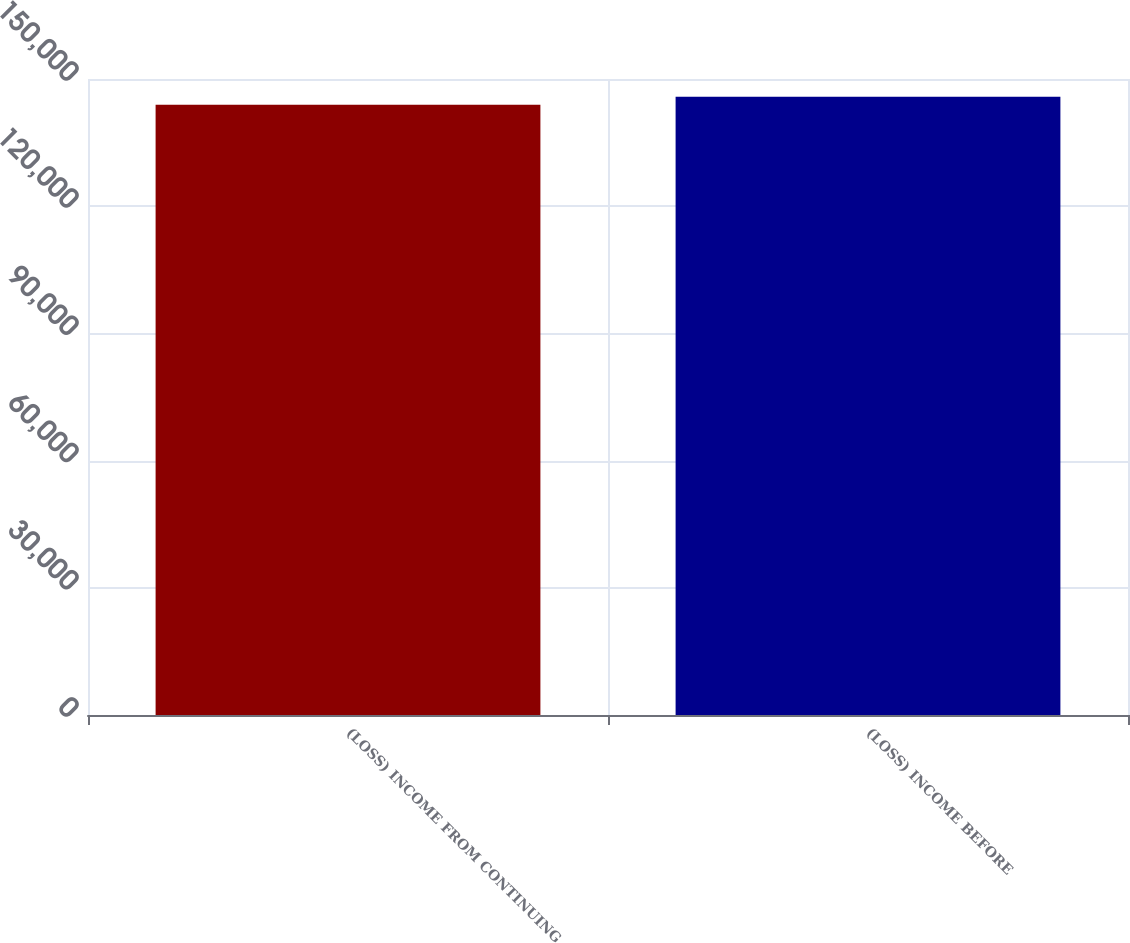Convert chart. <chart><loc_0><loc_0><loc_500><loc_500><bar_chart><fcel>(LOSS) INCOME FROM CONTINUING<fcel>(LOSS) INCOME BEFORE<nl><fcel>143921<fcel>145834<nl></chart> 